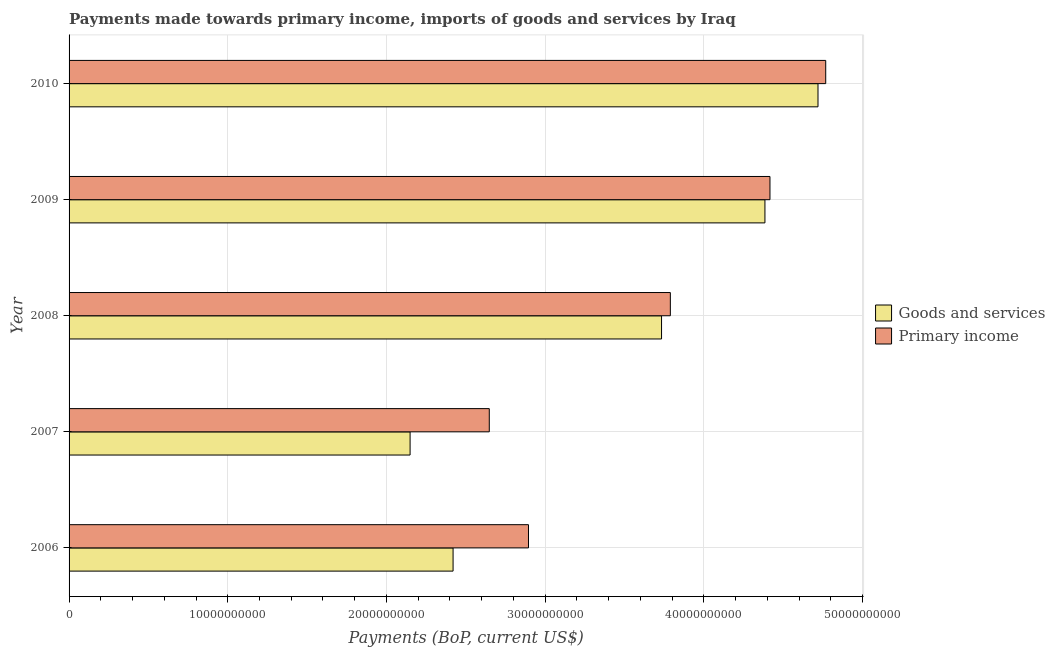How many different coloured bars are there?
Offer a very short reply. 2. How many groups of bars are there?
Keep it short and to the point. 5. Are the number of bars on each tick of the Y-axis equal?
Offer a terse response. Yes. In how many cases, is the number of bars for a given year not equal to the number of legend labels?
Provide a short and direct response. 0. What is the payments made towards goods and services in 2007?
Provide a short and direct response. 2.15e+1. Across all years, what is the maximum payments made towards primary income?
Provide a succinct answer. 4.77e+1. Across all years, what is the minimum payments made towards goods and services?
Give a very brief answer. 2.15e+1. In which year was the payments made towards goods and services maximum?
Your answer should be compact. 2010. What is the total payments made towards primary income in the graph?
Your answer should be compact. 1.85e+11. What is the difference between the payments made towards goods and services in 2009 and that in 2010?
Make the answer very short. -3.34e+09. What is the difference between the payments made towards goods and services in 2010 and the payments made towards primary income in 2008?
Ensure brevity in your answer.  9.30e+09. What is the average payments made towards primary income per year?
Your answer should be compact. 3.70e+1. In the year 2008, what is the difference between the payments made towards primary income and payments made towards goods and services?
Ensure brevity in your answer.  5.54e+08. In how many years, is the payments made towards primary income greater than 28000000000 US$?
Provide a short and direct response. 4. What is the ratio of the payments made towards primary income in 2006 to that in 2008?
Give a very brief answer. 0.76. Is the difference between the payments made towards primary income in 2007 and 2008 greater than the difference between the payments made towards goods and services in 2007 and 2008?
Offer a very short reply. Yes. What is the difference between the highest and the second highest payments made towards goods and services?
Keep it short and to the point. 3.34e+09. What is the difference between the highest and the lowest payments made towards goods and services?
Your answer should be compact. 2.57e+1. Is the sum of the payments made towards primary income in 2008 and 2009 greater than the maximum payments made towards goods and services across all years?
Your answer should be compact. Yes. What does the 2nd bar from the top in 2009 represents?
Offer a very short reply. Goods and services. What does the 1st bar from the bottom in 2009 represents?
Your answer should be very brief. Goods and services. How many bars are there?
Provide a short and direct response. 10. What is the difference between two consecutive major ticks on the X-axis?
Ensure brevity in your answer.  1.00e+1. Are the values on the major ticks of X-axis written in scientific E-notation?
Ensure brevity in your answer.  No. Does the graph contain any zero values?
Your answer should be very brief. No. Does the graph contain grids?
Your answer should be compact. Yes. Where does the legend appear in the graph?
Your answer should be very brief. Center right. What is the title of the graph?
Make the answer very short. Payments made towards primary income, imports of goods and services by Iraq. Does "RDB concessional" appear as one of the legend labels in the graph?
Your answer should be very brief. No. What is the label or title of the X-axis?
Your answer should be very brief. Payments (BoP, current US$). What is the label or title of the Y-axis?
Provide a short and direct response. Year. What is the Payments (BoP, current US$) in Goods and services in 2006?
Your response must be concise. 2.42e+1. What is the Payments (BoP, current US$) of Primary income in 2006?
Offer a very short reply. 2.89e+1. What is the Payments (BoP, current US$) in Goods and services in 2007?
Your response must be concise. 2.15e+1. What is the Payments (BoP, current US$) in Primary income in 2007?
Your answer should be compact. 2.65e+1. What is the Payments (BoP, current US$) in Goods and services in 2008?
Your answer should be compact. 3.73e+1. What is the Payments (BoP, current US$) in Primary income in 2008?
Your response must be concise. 3.79e+1. What is the Payments (BoP, current US$) in Goods and services in 2009?
Offer a very short reply. 4.38e+1. What is the Payments (BoP, current US$) of Primary income in 2009?
Your answer should be very brief. 4.42e+1. What is the Payments (BoP, current US$) of Goods and services in 2010?
Give a very brief answer. 4.72e+1. What is the Payments (BoP, current US$) in Primary income in 2010?
Offer a very short reply. 4.77e+1. Across all years, what is the maximum Payments (BoP, current US$) in Goods and services?
Provide a short and direct response. 4.72e+1. Across all years, what is the maximum Payments (BoP, current US$) in Primary income?
Make the answer very short. 4.77e+1. Across all years, what is the minimum Payments (BoP, current US$) of Goods and services?
Give a very brief answer. 2.15e+1. Across all years, what is the minimum Payments (BoP, current US$) in Primary income?
Keep it short and to the point. 2.65e+1. What is the total Payments (BoP, current US$) in Goods and services in the graph?
Give a very brief answer. 1.74e+11. What is the total Payments (BoP, current US$) of Primary income in the graph?
Make the answer very short. 1.85e+11. What is the difference between the Payments (BoP, current US$) in Goods and services in 2006 and that in 2007?
Provide a succinct answer. 2.71e+09. What is the difference between the Payments (BoP, current US$) in Primary income in 2006 and that in 2007?
Your answer should be very brief. 2.47e+09. What is the difference between the Payments (BoP, current US$) in Goods and services in 2006 and that in 2008?
Your answer should be very brief. -1.31e+1. What is the difference between the Payments (BoP, current US$) of Primary income in 2006 and that in 2008?
Provide a short and direct response. -8.94e+09. What is the difference between the Payments (BoP, current US$) of Goods and services in 2006 and that in 2009?
Offer a very short reply. -1.97e+1. What is the difference between the Payments (BoP, current US$) in Primary income in 2006 and that in 2009?
Provide a succinct answer. -1.52e+1. What is the difference between the Payments (BoP, current US$) in Goods and services in 2006 and that in 2010?
Your answer should be compact. -2.30e+1. What is the difference between the Payments (BoP, current US$) in Primary income in 2006 and that in 2010?
Give a very brief answer. -1.87e+1. What is the difference between the Payments (BoP, current US$) of Goods and services in 2007 and that in 2008?
Your answer should be compact. -1.58e+1. What is the difference between the Payments (BoP, current US$) in Primary income in 2007 and that in 2008?
Give a very brief answer. -1.14e+1. What is the difference between the Payments (BoP, current US$) of Goods and services in 2007 and that in 2009?
Provide a succinct answer. -2.24e+1. What is the difference between the Payments (BoP, current US$) in Primary income in 2007 and that in 2009?
Provide a short and direct response. -1.77e+1. What is the difference between the Payments (BoP, current US$) of Goods and services in 2007 and that in 2010?
Give a very brief answer. -2.57e+1. What is the difference between the Payments (BoP, current US$) of Primary income in 2007 and that in 2010?
Ensure brevity in your answer.  -2.12e+1. What is the difference between the Payments (BoP, current US$) of Goods and services in 2008 and that in 2009?
Offer a very short reply. -6.51e+09. What is the difference between the Payments (BoP, current US$) in Primary income in 2008 and that in 2009?
Provide a short and direct response. -6.28e+09. What is the difference between the Payments (BoP, current US$) in Goods and services in 2008 and that in 2010?
Your answer should be compact. -9.86e+09. What is the difference between the Payments (BoP, current US$) of Primary income in 2008 and that in 2010?
Your answer should be very brief. -9.79e+09. What is the difference between the Payments (BoP, current US$) of Goods and services in 2009 and that in 2010?
Your answer should be compact. -3.34e+09. What is the difference between the Payments (BoP, current US$) of Primary income in 2009 and that in 2010?
Provide a succinct answer. -3.51e+09. What is the difference between the Payments (BoP, current US$) of Goods and services in 2006 and the Payments (BoP, current US$) of Primary income in 2007?
Provide a succinct answer. -2.28e+09. What is the difference between the Payments (BoP, current US$) in Goods and services in 2006 and the Payments (BoP, current US$) in Primary income in 2008?
Offer a terse response. -1.37e+1. What is the difference between the Payments (BoP, current US$) in Goods and services in 2006 and the Payments (BoP, current US$) in Primary income in 2009?
Ensure brevity in your answer.  -2.00e+1. What is the difference between the Payments (BoP, current US$) of Goods and services in 2006 and the Payments (BoP, current US$) of Primary income in 2010?
Make the answer very short. -2.35e+1. What is the difference between the Payments (BoP, current US$) of Goods and services in 2007 and the Payments (BoP, current US$) of Primary income in 2008?
Ensure brevity in your answer.  -1.64e+1. What is the difference between the Payments (BoP, current US$) in Goods and services in 2007 and the Payments (BoP, current US$) in Primary income in 2009?
Your answer should be compact. -2.27e+1. What is the difference between the Payments (BoP, current US$) in Goods and services in 2007 and the Payments (BoP, current US$) in Primary income in 2010?
Your answer should be compact. -2.62e+1. What is the difference between the Payments (BoP, current US$) of Goods and services in 2008 and the Payments (BoP, current US$) of Primary income in 2009?
Provide a succinct answer. -6.83e+09. What is the difference between the Payments (BoP, current US$) of Goods and services in 2008 and the Payments (BoP, current US$) of Primary income in 2010?
Provide a succinct answer. -1.03e+1. What is the difference between the Payments (BoP, current US$) of Goods and services in 2009 and the Payments (BoP, current US$) of Primary income in 2010?
Offer a terse response. -3.83e+09. What is the average Payments (BoP, current US$) in Goods and services per year?
Your response must be concise. 3.48e+1. What is the average Payments (BoP, current US$) in Primary income per year?
Your answer should be very brief. 3.70e+1. In the year 2006, what is the difference between the Payments (BoP, current US$) in Goods and services and Payments (BoP, current US$) in Primary income?
Your answer should be compact. -4.75e+09. In the year 2007, what is the difference between the Payments (BoP, current US$) in Goods and services and Payments (BoP, current US$) in Primary income?
Keep it short and to the point. -4.99e+09. In the year 2008, what is the difference between the Payments (BoP, current US$) in Goods and services and Payments (BoP, current US$) in Primary income?
Make the answer very short. -5.54e+08. In the year 2009, what is the difference between the Payments (BoP, current US$) in Goods and services and Payments (BoP, current US$) in Primary income?
Give a very brief answer. -3.17e+08. In the year 2010, what is the difference between the Payments (BoP, current US$) in Goods and services and Payments (BoP, current US$) in Primary income?
Your response must be concise. -4.87e+08. What is the ratio of the Payments (BoP, current US$) of Goods and services in 2006 to that in 2007?
Your answer should be compact. 1.13. What is the ratio of the Payments (BoP, current US$) of Primary income in 2006 to that in 2007?
Keep it short and to the point. 1.09. What is the ratio of the Payments (BoP, current US$) in Goods and services in 2006 to that in 2008?
Make the answer very short. 0.65. What is the ratio of the Payments (BoP, current US$) in Primary income in 2006 to that in 2008?
Your answer should be very brief. 0.76. What is the ratio of the Payments (BoP, current US$) in Goods and services in 2006 to that in 2009?
Offer a terse response. 0.55. What is the ratio of the Payments (BoP, current US$) of Primary income in 2006 to that in 2009?
Your answer should be very brief. 0.66. What is the ratio of the Payments (BoP, current US$) in Goods and services in 2006 to that in 2010?
Provide a succinct answer. 0.51. What is the ratio of the Payments (BoP, current US$) of Primary income in 2006 to that in 2010?
Ensure brevity in your answer.  0.61. What is the ratio of the Payments (BoP, current US$) of Goods and services in 2007 to that in 2008?
Offer a terse response. 0.58. What is the ratio of the Payments (BoP, current US$) of Primary income in 2007 to that in 2008?
Your answer should be very brief. 0.7. What is the ratio of the Payments (BoP, current US$) in Goods and services in 2007 to that in 2009?
Your response must be concise. 0.49. What is the ratio of the Payments (BoP, current US$) of Primary income in 2007 to that in 2009?
Your response must be concise. 0.6. What is the ratio of the Payments (BoP, current US$) in Goods and services in 2007 to that in 2010?
Your answer should be very brief. 0.46. What is the ratio of the Payments (BoP, current US$) in Primary income in 2007 to that in 2010?
Offer a very short reply. 0.56. What is the ratio of the Payments (BoP, current US$) of Goods and services in 2008 to that in 2009?
Your response must be concise. 0.85. What is the ratio of the Payments (BoP, current US$) in Primary income in 2008 to that in 2009?
Give a very brief answer. 0.86. What is the ratio of the Payments (BoP, current US$) of Goods and services in 2008 to that in 2010?
Provide a short and direct response. 0.79. What is the ratio of the Payments (BoP, current US$) in Primary income in 2008 to that in 2010?
Make the answer very short. 0.79. What is the ratio of the Payments (BoP, current US$) of Goods and services in 2009 to that in 2010?
Give a very brief answer. 0.93. What is the ratio of the Payments (BoP, current US$) in Primary income in 2009 to that in 2010?
Ensure brevity in your answer.  0.93. What is the difference between the highest and the second highest Payments (BoP, current US$) of Goods and services?
Make the answer very short. 3.34e+09. What is the difference between the highest and the second highest Payments (BoP, current US$) of Primary income?
Offer a terse response. 3.51e+09. What is the difference between the highest and the lowest Payments (BoP, current US$) in Goods and services?
Ensure brevity in your answer.  2.57e+1. What is the difference between the highest and the lowest Payments (BoP, current US$) of Primary income?
Offer a very short reply. 2.12e+1. 